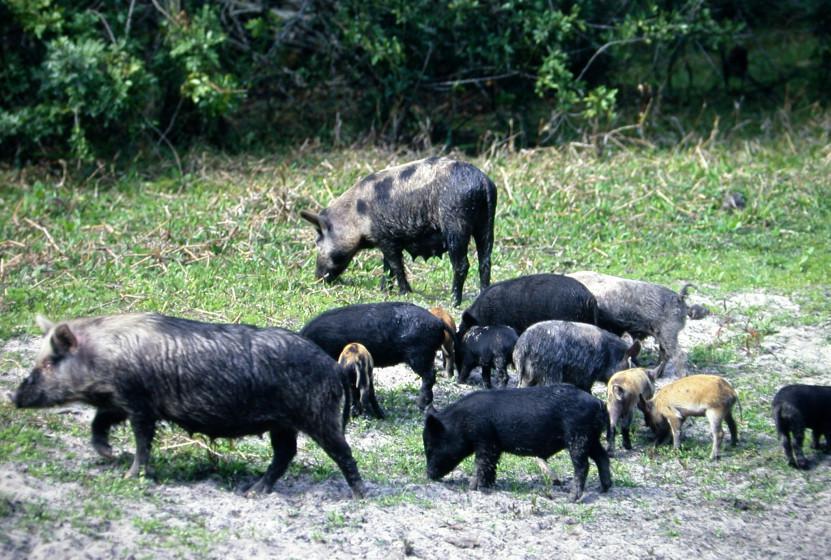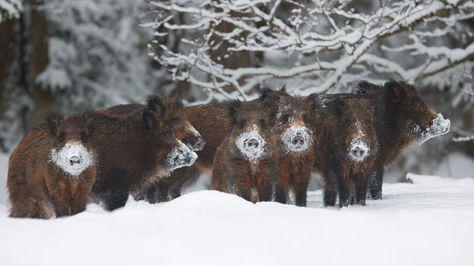The first image is the image on the left, the second image is the image on the right. Given the left and right images, does the statement "there are no more than three boars in one of the images" hold true? Answer yes or no. No. The first image is the image on the left, the second image is the image on the right. For the images shown, is this caption "An image contains no more than 8 hogs, with at least half standing facing forward." true? Answer yes or no. Yes. 